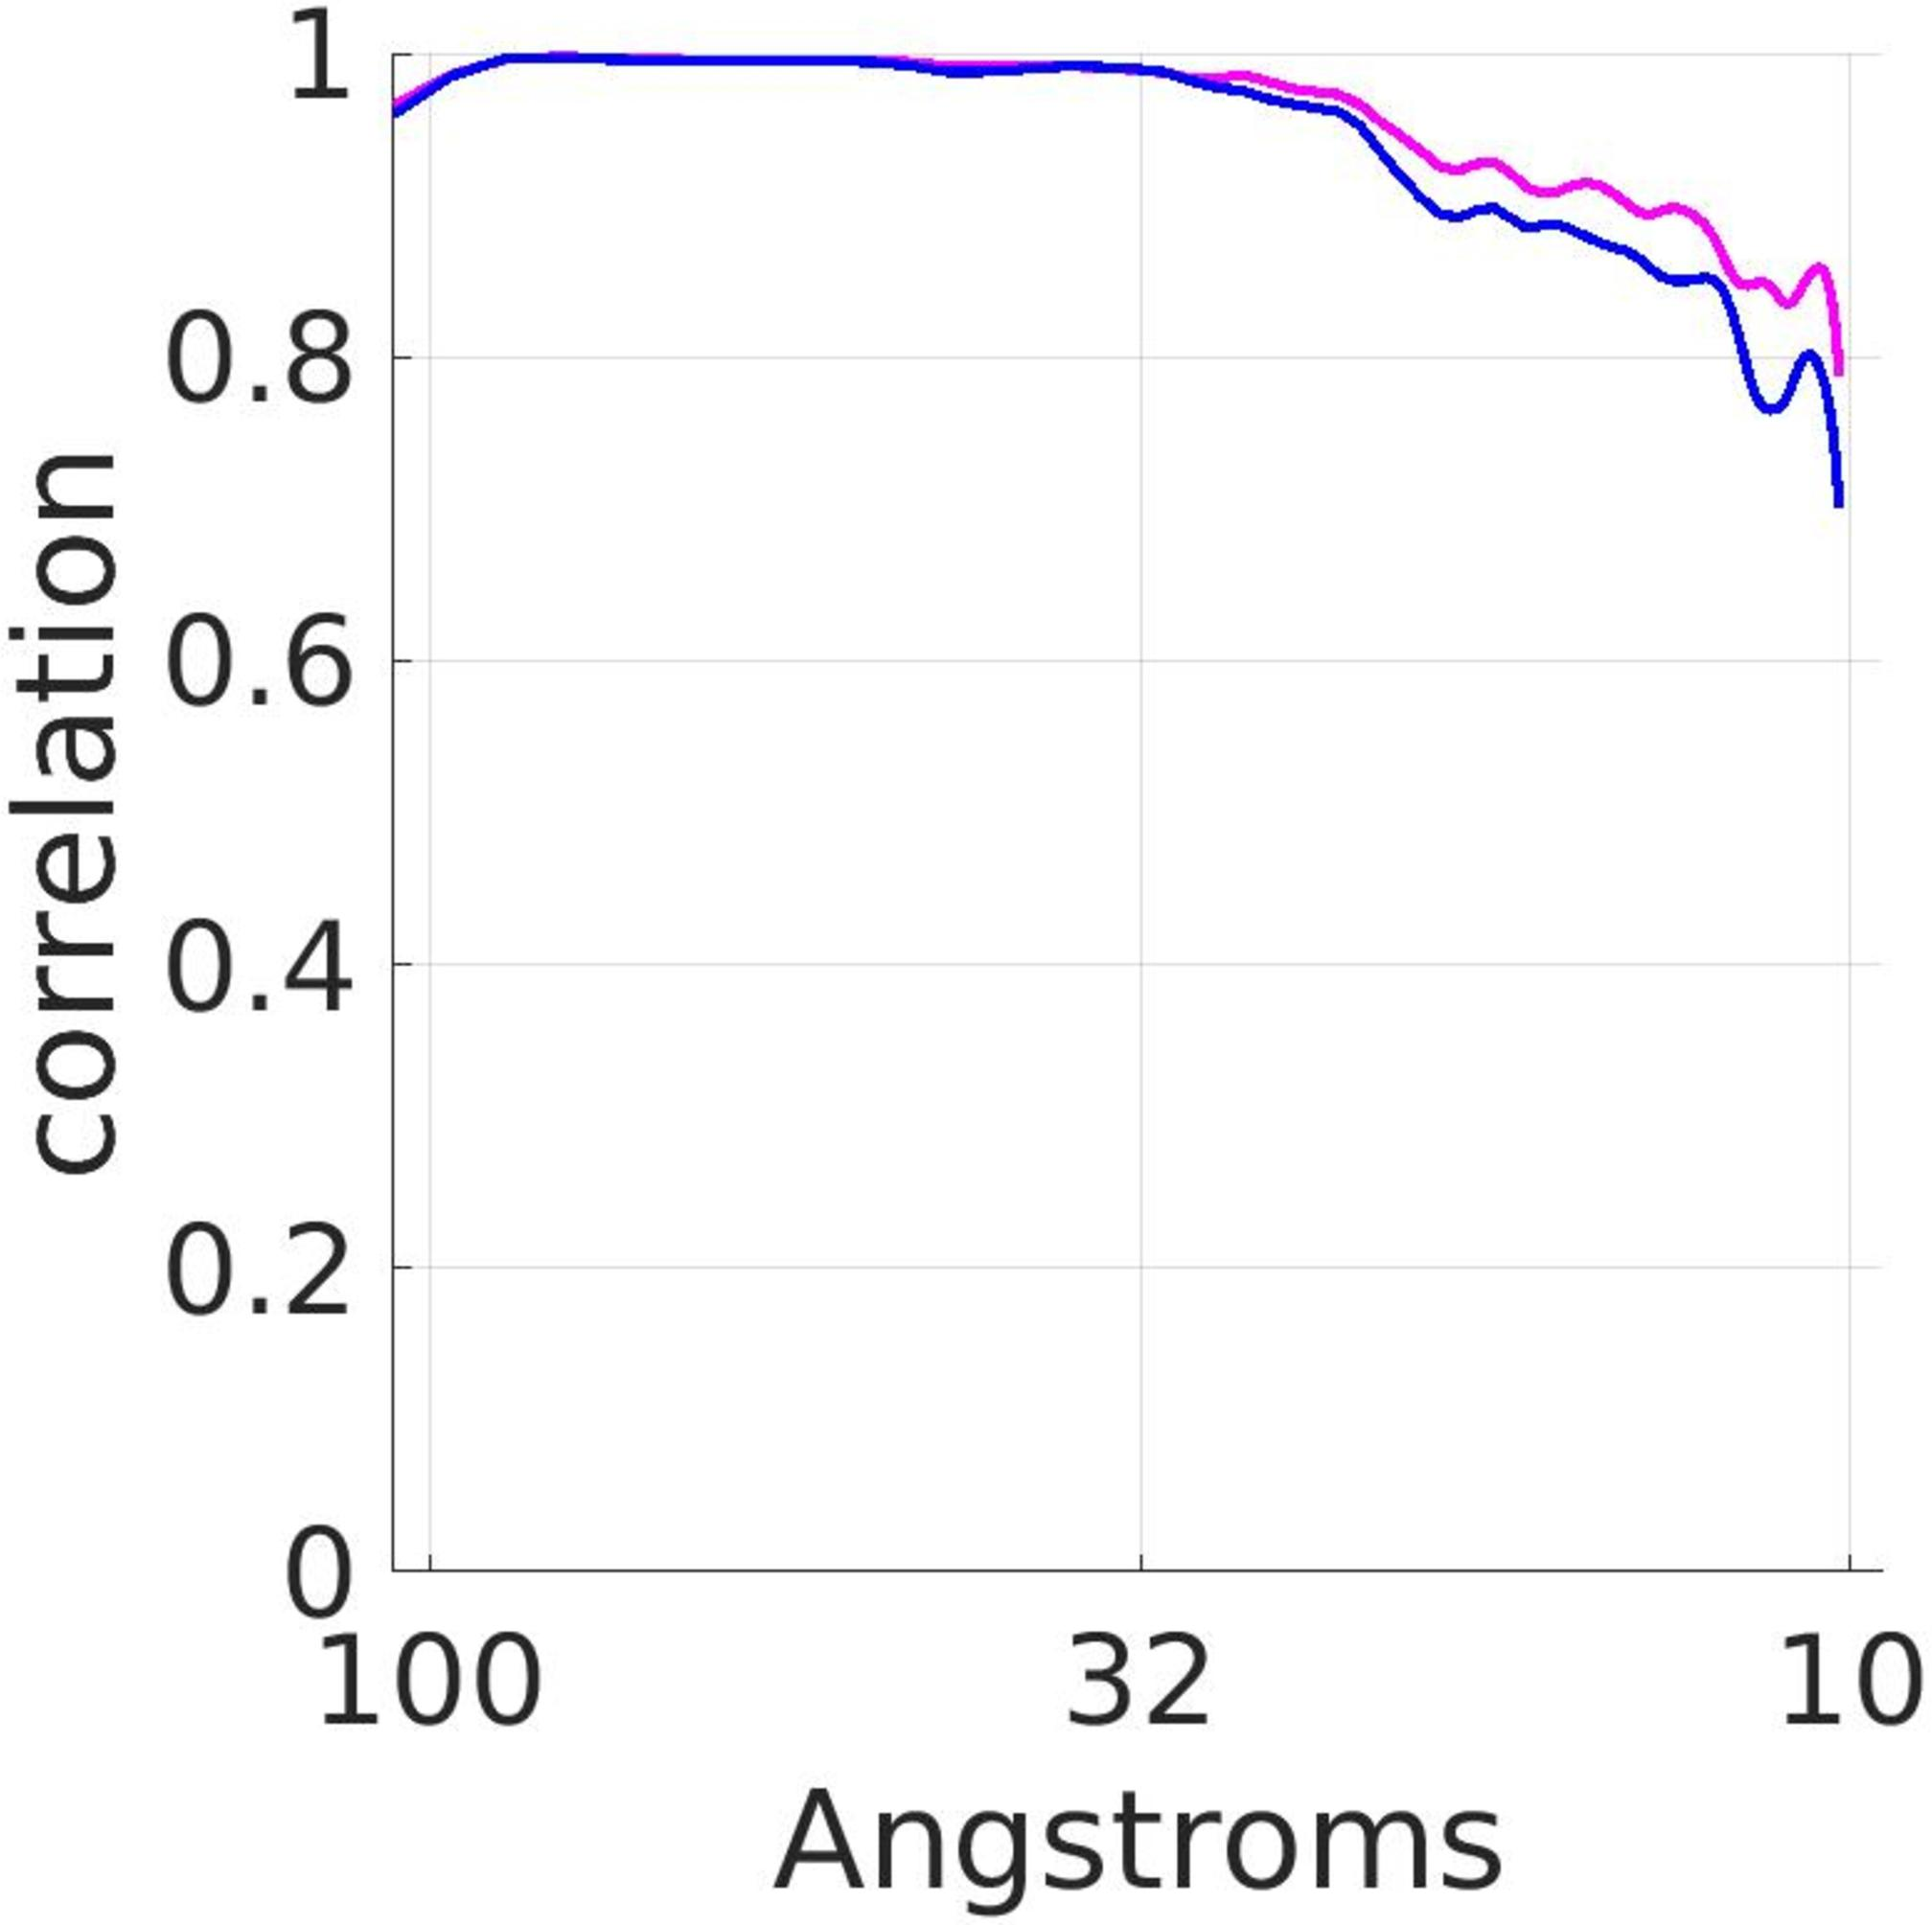If the pattern observed in the graph continues beyond the range shown, what would be the expected correlation value at 200 angstroms? Approximately 0.2 Approximately 0.5 Approximately 0.8 The pattern cannot be reliably extended to 200 angstroms. Analyzing the graph showing correlation as a function of distance in angstroms, it's clear that the correlation value steadily decreases as the distance increases. Given the variability in the data and the drop in correlation values as displayed, predicting accurate correlation at 200 angstroms is not scientifically reliable without additional data points or a more robust trending analysis within this range. Therefore, extending the pattern to 200 angstroms could lead to significant errors in estimation, rendering any specific extrapolation like 0.2, 0.5, or 0.8 as quite speculative. It’s crucial in scientific practice to acknowledge when a trend cannot be confidently extended due to the lack of data, as is the case here. 